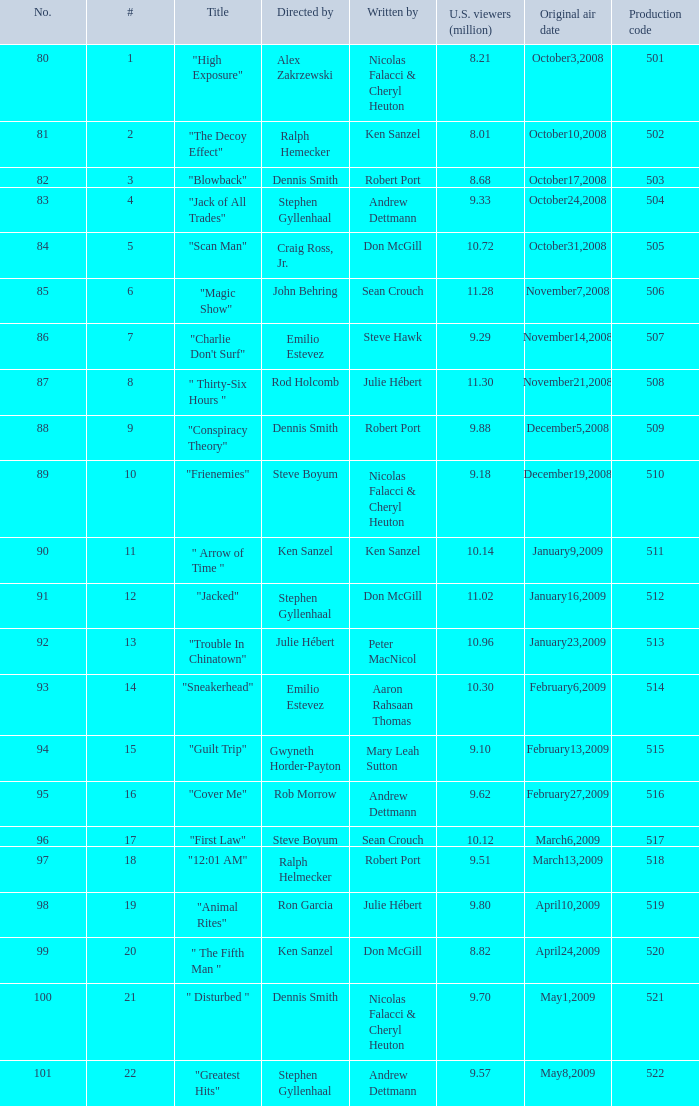Which episode attracted 10.14 million viewers in the u.s.? 11.0. 